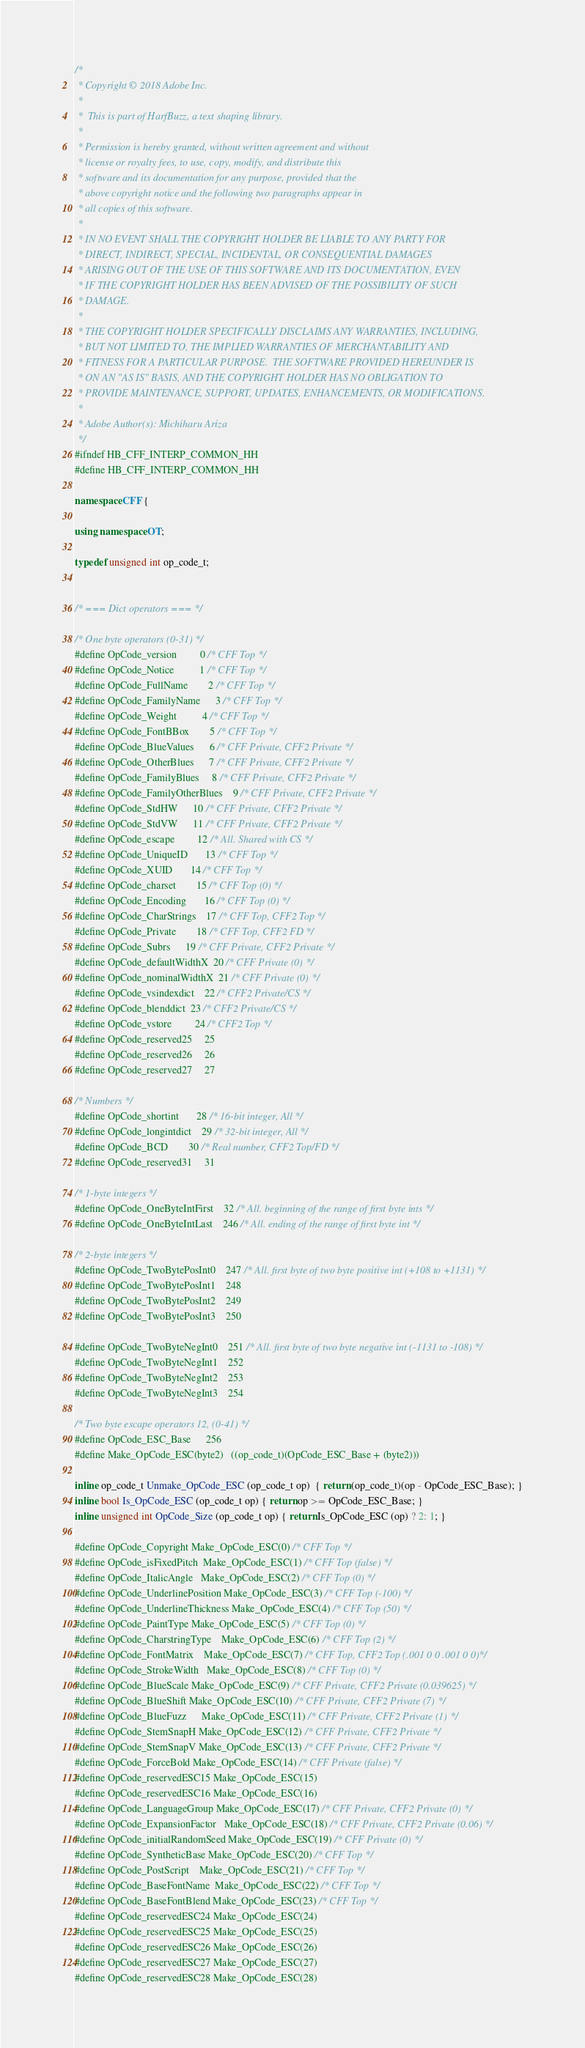<code> <loc_0><loc_0><loc_500><loc_500><_C++_>/*
 * Copyright © 2018 Adobe Inc.
 *
 *  This is part of HarfBuzz, a text shaping library.
 *
 * Permission is hereby granted, without written agreement and without
 * license or royalty fees, to use, copy, modify, and distribute this
 * software and its documentation for any purpose, provided that the
 * above copyright notice and the following two paragraphs appear in
 * all copies of this software.
 *
 * IN NO EVENT SHALL THE COPYRIGHT HOLDER BE LIABLE TO ANY PARTY FOR
 * DIRECT, INDIRECT, SPECIAL, INCIDENTAL, OR CONSEQUENTIAL DAMAGES
 * ARISING OUT OF THE USE OF THIS SOFTWARE AND ITS DOCUMENTATION, EVEN
 * IF THE COPYRIGHT HOLDER HAS BEEN ADVISED OF THE POSSIBILITY OF SUCH
 * DAMAGE.
 *
 * THE COPYRIGHT HOLDER SPECIFICALLY DISCLAIMS ANY WARRANTIES, INCLUDING,
 * BUT NOT LIMITED TO, THE IMPLIED WARRANTIES OF MERCHANTABILITY AND
 * FITNESS FOR A PARTICULAR PURPOSE.  THE SOFTWARE PROVIDED HEREUNDER IS
 * ON AN "AS IS" BASIS, AND THE COPYRIGHT HOLDER HAS NO OBLIGATION TO
 * PROVIDE MAINTENANCE, SUPPORT, UPDATES, ENHANCEMENTS, OR MODIFICATIONS.
 *
 * Adobe Author(s): Michiharu Ariza
 */
#ifndef HB_CFF_INTERP_COMMON_HH
#define HB_CFF_INTERP_COMMON_HH

namespace CFF {

using namespace OT;

typedef unsigned int op_code_t;


/* === Dict operators === */

/* One byte operators (0-31) */
#define OpCode_version		  0 /* CFF Top */
#define OpCode_Notice		  1 /* CFF Top */
#define OpCode_FullName		  2 /* CFF Top */
#define OpCode_FamilyName	  3 /* CFF Top */
#define OpCode_Weight		  4 /* CFF Top */
#define OpCode_FontBBox		  5 /* CFF Top */
#define OpCode_BlueValues	  6 /* CFF Private, CFF2 Private */
#define OpCode_OtherBlues	  7 /* CFF Private, CFF2 Private */
#define OpCode_FamilyBlues	  8 /* CFF Private, CFF2 Private */
#define OpCode_FamilyOtherBlues	  9 /* CFF Private, CFF2 Private */
#define OpCode_StdHW		 10 /* CFF Private, CFF2 Private */
#define OpCode_StdVW		 11 /* CFF Private, CFF2 Private */
#define OpCode_escape		 12 /* All. Shared with CS */
#define OpCode_UniqueID		 13 /* CFF Top */
#define OpCode_XUID		 14 /* CFF Top */
#define OpCode_charset		 15 /* CFF Top (0) */
#define OpCode_Encoding		 16 /* CFF Top (0) */
#define OpCode_CharStrings	 17 /* CFF Top, CFF2 Top */
#define OpCode_Private		 18 /* CFF Top, CFF2 FD */
#define OpCode_Subrs		 19 /* CFF Private, CFF2 Private */
#define OpCode_defaultWidthX	 20 /* CFF Private (0) */
#define OpCode_nominalWidthX	 21 /* CFF Private (0) */
#define OpCode_vsindexdict	 22 /* CFF2 Private/CS */
#define OpCode_blenddict	 23 /* CFF2 Private/CS */
#define OpCode_vstore		 24 /* CFF2 Top */
#define OpCode_reserved25	 25
#define OpCode_reserved26	 26
#define OpCode_reserved27	 27

/* Numbers */
#define OpCode_shortint		 28 /* 16-bit integer, All */
#define OpCode_longintdict	 29 /* 32-bit integer, All */
#define OpCode_BCD		 30 /* Real number, CFF2 Top/FD */
#define OpCode_reserved31	 31

/* 1-byte integers */
#define OpCode_OneByteIntFirst	 32 /* All. beginning of the range of first byte ints */
#define OpCode_OneByteIntLast	246 /* All. ending of the range of first byte int */

/* 2-byte integers */
#define OpCode_TwoBytePosInt0	247 /* All. first byte of two byte positive int (+108 to +1131) */
#define OpCode_TwoBytePosInt1	248
#define OpCode_TwoBytePosInt2	249
#define OpCode_TwoBytePosInt3	250

#define OpCode_TwoByteNegInt0	251 /* All. first byte of two byte negative int (-1131 to -108) */
#define OpCode_TwoByteNegInt1	252
#define OpCode_TwoByteNegInt2	253
#define OpCode_TwoByteNegInt3	254

/* Two byte escape operators 12, (0-41) */
#define OpCode_ESC_Base		256
#define Make_OpCode_ESC(byte2)	((op_code_t)(OpCode_ESC_Base + (byte2)))

inline op_code_t Unmake_OpCode_ESC (op_code_t op)  { return (op_code_t)(op - OpCode_ESC_Base); }
inline bool Is_OpCode_ESC (op_code_t op) { return op >= OpCode_ESC_Base; }
inline unsigned int OpCode_Size (op_code_t op) { return Is_OpCode_ESC (op) ? 2: 1; }

#define OpCode_Copyright	Make_OpCode_ESC(0) /* CFF Top */
#define OpCode_isFixedPitch	Make_OpCode_ESC(1) /* CFF Top (false) */
#define OpCode_ItalicAngle	Make_OpCode_ESC(2) /* CFF Top (0) */
#define OpCode_UnderlinePosition Make_OpCode_ESC(3) /* CFF Top (-100) */
#define OpCode_UnderlineThickness Make_OpCode_ESC(4) /* CFF Top (50) */
#define OpCode_PaintType	Make_OpCode_ESC(5) /* CFF Top (0) */
#define OpCode_CharstringType	Make_OpCode_ESC(6) /* CFF Top (2) */
#define OpCode_FontMatrix	Make_OpCode_ESC(7) /* CFF Top, CFF2 Top (.001 0 0 .001 0 0)*/
#define OpCode_StrokeWidth	Make_OpCode_ESC(8) /* CFF Top (0) */
#define OpCode_BlueScale	Make_OpCode_ESC(9) /* CFF Private, CFF2 Private (0.039625) */
#define OpCode_BlueShift	Make_OpCode_ESC(10) /* CFF Private, CFF2 Private (7) */
#define OpCode_BlueFuzz		Make_OpCode_ESC(11) /* CFF Private, CFF2 Private (1) */
#define OpCode_StemSnapH	Make_OpCode_ESC(12) /* CFF Private, CFF2 Private */
#define OpCode_StemSnapV	Make_OpCode_ESC(13) /* CFF Private, CFF2 Private */
#define OpCode_ForceBold	Make_OpCode_ESC(14) /* CFF Private (false) */
#define OpCode_reservedESC15	Make_OpCode_ESC(15)
#define OpCode_reservedESC16	Make_OpCode_ESC(16)
#define OpCode_LanguageGroup	Make_OpCode_ESC(17) /* CFF Private, CFF2 Private (0) */
#define OpCode_ExpansionFactor	Make_OpCode_ESC(18) /* CFF Private, CFF2 Private (0.06) */
#define OpCode_initialRandomSeed Make_OpCode_ESC(19) /* CFF Private (0) */
#define OpCode_SyntheticBase	Make_OpCode_ESC(20) /* CFF Top */
#define OpCode_PostScript	Make_OpCode_ESC(21) /* CFF Top */
#define OpCode_BaseFontName	Make_OpCode_ESC(22) /* CFF Top */
#define OpCode_BaseFontBlend	Make_OpCode_ESC(23) /* CFF Top */
#define OpCode_reservedESC24	Make_OpCode_ESC(24)
#define OpCode_reservedESC25	Make_OpCode_ESC(25)
#define OpCode_reservedESC26	Make_OpCode_ESC(26)
#define OpCode_reservedESC27	Make_OpCode_ESC(27)
#define OpCode_reservedESC28	Make_OpCode_ESC(28)</code> 